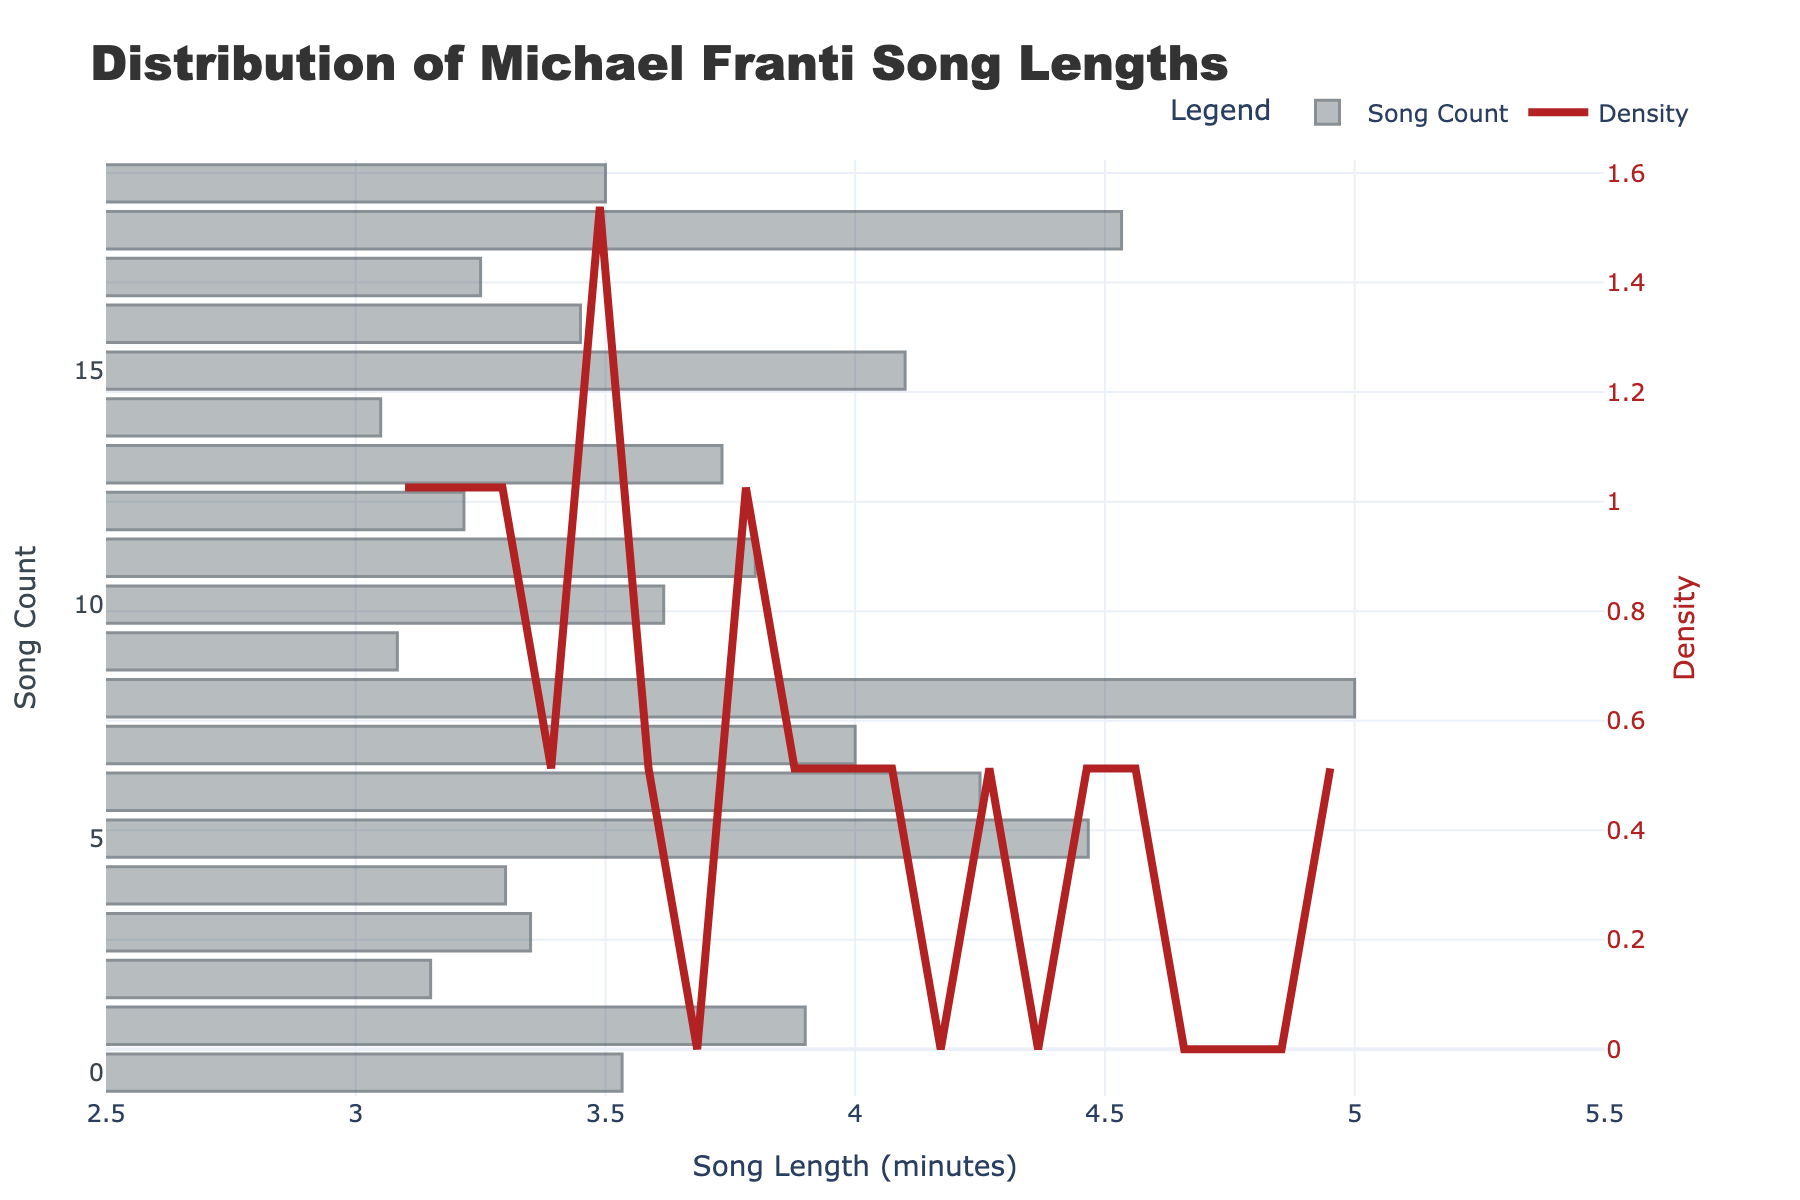What's the title of the plot? The title of the plot is prominently displayed at the top and reads "Distribution of Michael Franti Song Lengths".
Answer: Distribution of Michael Franti Song Lengths What does the x-axis represent? The x-axis title is "Song Length (minutes)", indicating it represents the duration of Michael Franti's songs in minutes.
Answer: Song Length (minutes) How many songs are in Michael Franti's discography according to the figure? The histogram bars represent individual songs, and by counting all the bars, we can determine the number of songs. There are 20 songs as indicated by the provided data.
Answer: 20 What's the range of song lengths in minutes shown on the x-axis? The x-axis is set to show a range between approximately 3.5 minutes and 4.5 minutes based on the distribution displayed in the plot.
Answer: Between 2.5 and 5.5 minutes What does the secondary y-axis represent, and how is it visually distinguished? The secondary y-axis represents the density of the song lengths, marked with the label "Density" and distinguished by the firebrick-colored density curve.
Answer: Density, firebrick line Which song length has the highest density according to the KDE curve? The highest peak of the KDE curve indicates the length with the highest density. This peak is approximately around 3.5 minutes.
Answer: Approximately 3.5 minutes Is there a song that lasts exactly 4 minutes? By examining the histogram, we can see there's no bar exactly at the 4-minute mark, so there is no song that lasts exactly 4 minutes.
Answer: No Compare the frequency of songs of 3 minutes and 4.5 minutes. Which length appears more frequently? Comparing the height of the bars at 3 minutes and 4.5 minutes on the histogram shows that songs around 3 minutes appear more frequently.
Answer: 3 minutes What is the approximate song length that lacks any songs according to the plot? The area around 4.5 minutes shows no histogram bars, indicating that no song in the dataset lasts approximately 4.5 minutes.
Answer: Approximately 4.5 minutes What's the overall trend observed in the distribution of song lengths? The histogram and the KDE curve together suggest that most songs range around 3 to 4 minutes, with the density gradually decreasing for longer song lengths beyond 4 minutes.
Answer: Most songs are 3 to 4 minutes long 